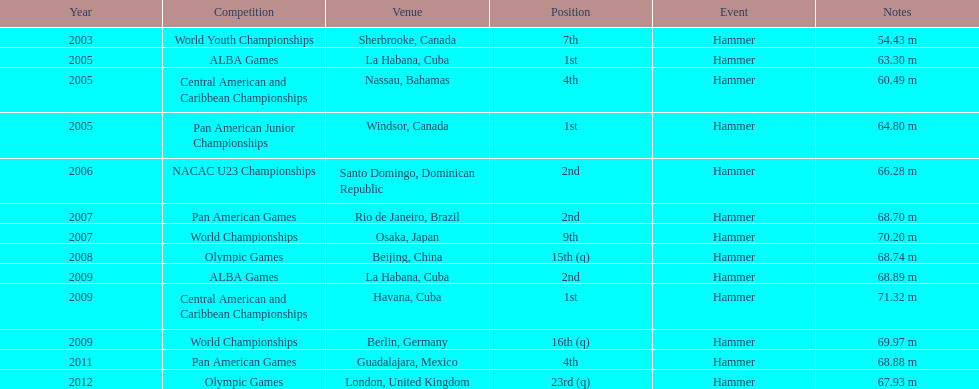What is the number of competitions held in cuba? 3. Parse the table in full. {'header': ['Year', 'Competition', 'Venue', 'Position', 'Event', 'Notes'], 'rows': [['2003', 'World Youth Championships', 'Sherbrooke, Canada', '7th', 'Hammer', '54.43 m'], ['2005', 'ALBA Games', 'La Habana, Cuba', '1st', 'Hammer', '63.30 m'], ['2005', 'Central American and Caribbean Championships', 'Nassau, Bahamas', '4th', 'Hammer', '60.49 m'], ['2005', 'Pan American Junior Championships', 'Windsor, Canada', '1st', 'Hammer', '64.80 m'], ['2006', 'NACAC U23 Championships', 'Santo Domingo, Dominican Republic', '2nd', 'Hammer', '66.28 m'], ['2007', 'Pan American Games', 'Rio de Janeiro, Brazil', '2nd', 'Hammer', '68.70 m'], ['2007', 'World Championships', 'Osaka, Japan', '9th', 'Hammer', '70.20 m'], ['2008', 'Olympic Games', 'Beijing, China', '15th (q)', 'Hammer', '68.74 m'], ['2009', 'ALBA Games', 'La Habana, Cuba', '2nd', 'Hammer', '68.89 m'], ['2009', 'Central American and Caribbean Championships', 'Havana, Cuba', '1st', 'Hammer', '71.32 m'], ['2009', 'World Championships', 'Berlin, Germany', '16th (q)', 'Hammer', '69.97 m'], ['2011', 'Pan American Games', 'Guadalajara, Mexico', '4th', 'Hammer', '68.88 m'], ['2012', 'Olympic Games', 'London, United Kingdom', '23rd (q)', 'Hammer', '67.93 m']]} 